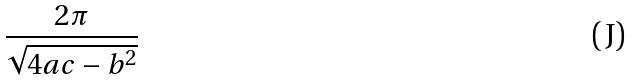Convert formula to latex. <formula><loc_0><loc_0><loc_500><loc_500>\frac { 2 \pi } { \sqrt { 4 a c - b ^ { 2 } } }</formula> 